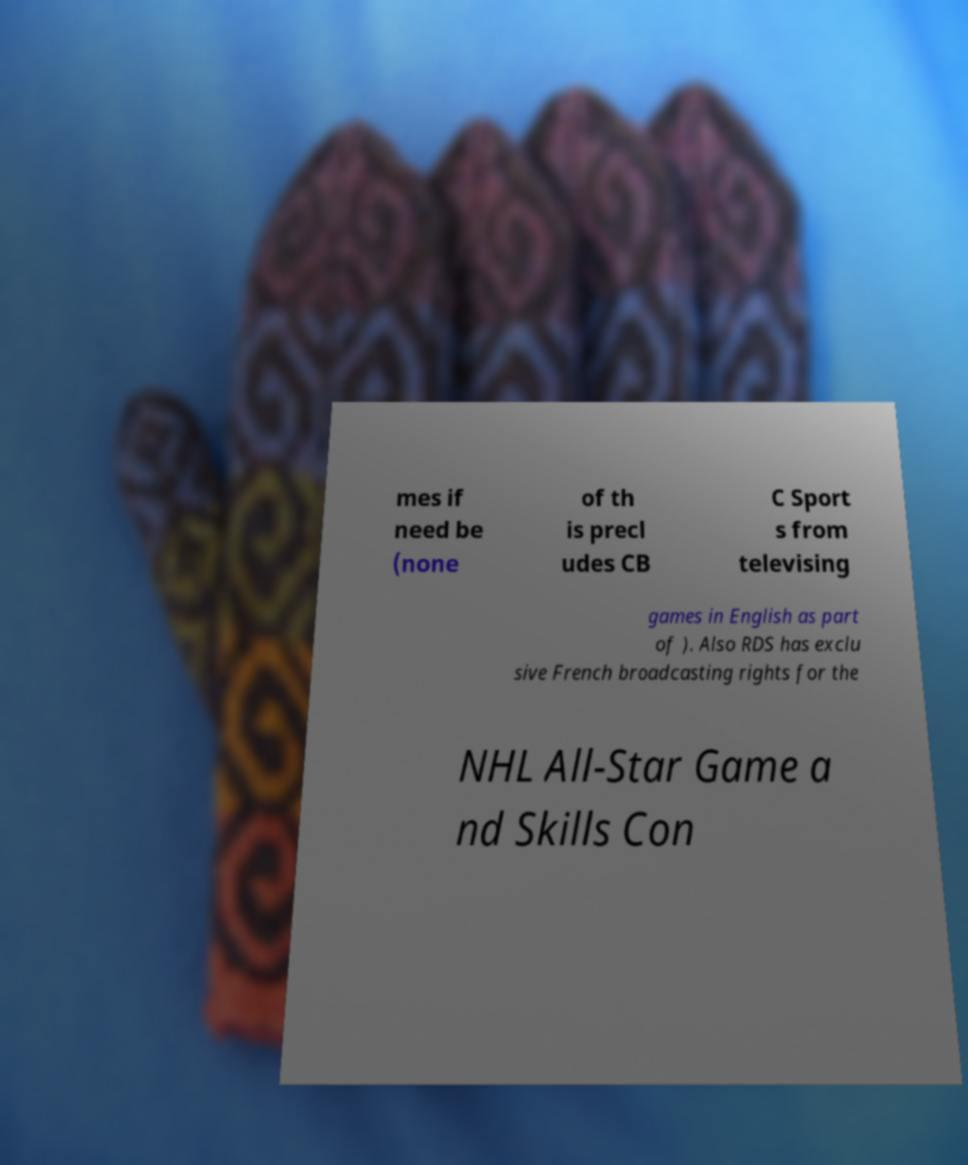Can you read and provide the text displayed in the image?This photo seems to have some interesting text. Can you extract and type it out for me? mes if need be (none of th is precl udes CB C Sport s from televising games in English as part of ). Also RDS has exclu sive French broadcasting rights for the NHL All-Star Game a nd Skills Con 